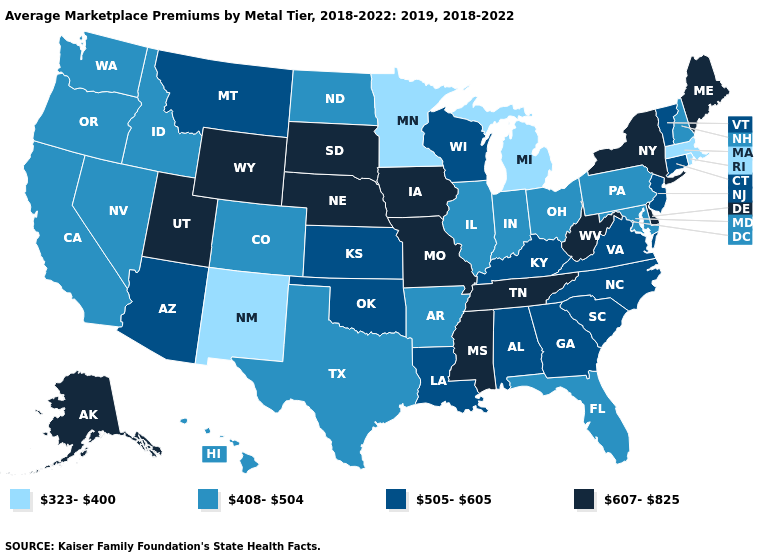Does the first symbol in the legend represent the smallest category?
Answer briefly. Yes. Among the states that border New York , does Connecticut have the highest value?
Keep it brief. Yes. What is the value of Vermont?
Give a very brief answer. 505-605. What is the value of Kentucky?
Concise answer only. 505-605. How many symbols are there in the legend?
Short answer required. 4. What is the value of California?
Write a very short answer. 408-504. Does West Virginia have the same value as Michigan?
Keep it brief. No. What is the value of Massachusetts?
Keep it brief. 323-400. What is the value of Pennsylvania?
Quick response, please. 408-504. What is the value of Arizona?
Write a very short answer. 505-605. Does Oklahoma have the same value as Florida?
Give a very brief answer. No. Which states have the highest value in the USA?
Answer briefly. Alaska, Delaware, Iowa, Maine, Mississippi, Missouri, Nebraska, New York, South Dakota, Tennessee, Utah, West Virginia, Wyoming. What is the value of Iowa?
Concise answer only. 607-825. Which states have the lowest value in the USA?
Concise answer only. Massachusetts, Michigan, Minnesota, New Mexico, Rhode Island. What is the lowest value in states that border Illinois?
Keep it brief. 408-504. 